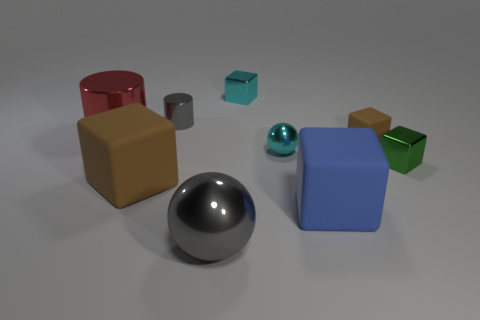Subtract all brown blocks. How many were subtracted if there are1brown blocks left? 1 Subtract all rubber blocks. How many blocks are left? 2 Add 1 big rubber objects. How many objects exist? 10 Subtract all cyan spheres. How many spheres are left? 1 Subtract all gray spheres. How many brown blocks are left? 2 Subtract all cylinders. How many objects are left? 7 Subtract 2 blocks. How many blocks are left? 3 Subtract all tiny metallic cubes. Subtract all cyan cubes. How many objects are left? 6 Add 5 tiny green shiny things. How many tiny green shiny things are left? 6 Add 7 small cyan objects. How many small cyan objects exist? 9 